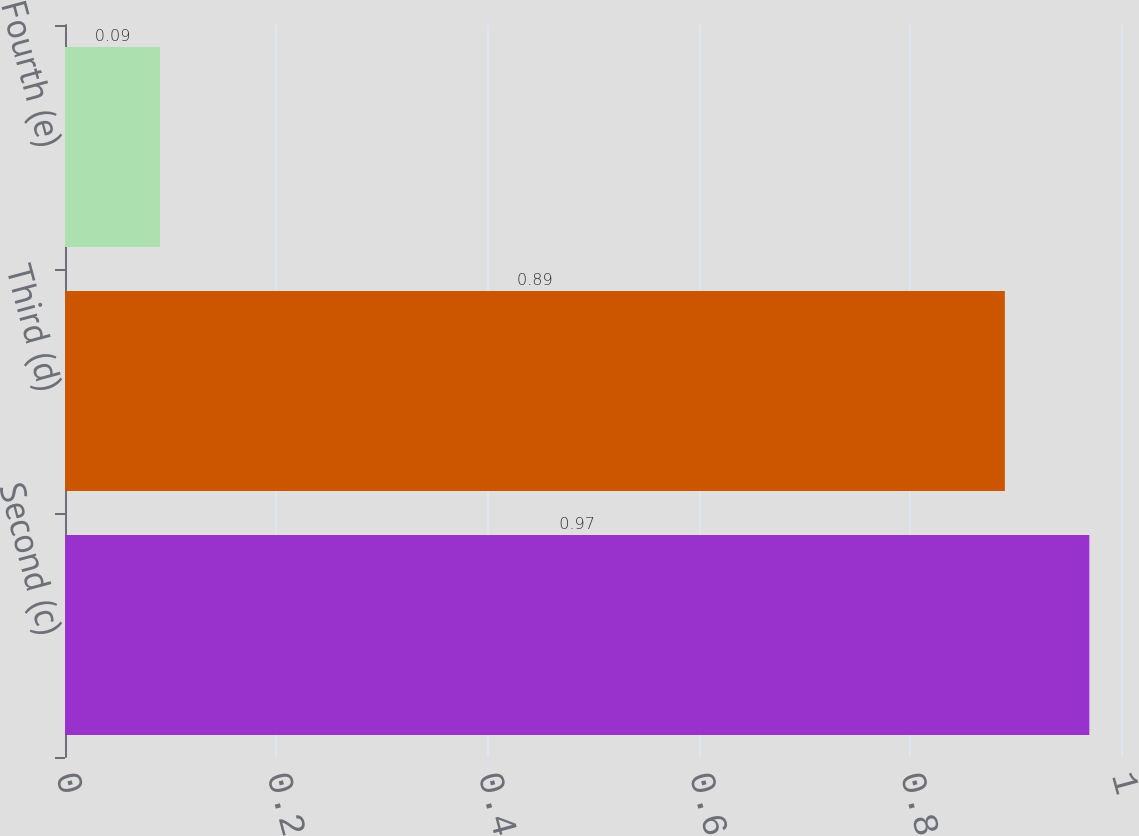<chart> <loc_0><loc_0><loc_500><loc_500><bar_chart><fcel>Second (c)<fcel>Third (d)<fcel>Fourth (e)<nl><fcel>0.97<fcel>0.89<fcel>0.09<nl></chart> 